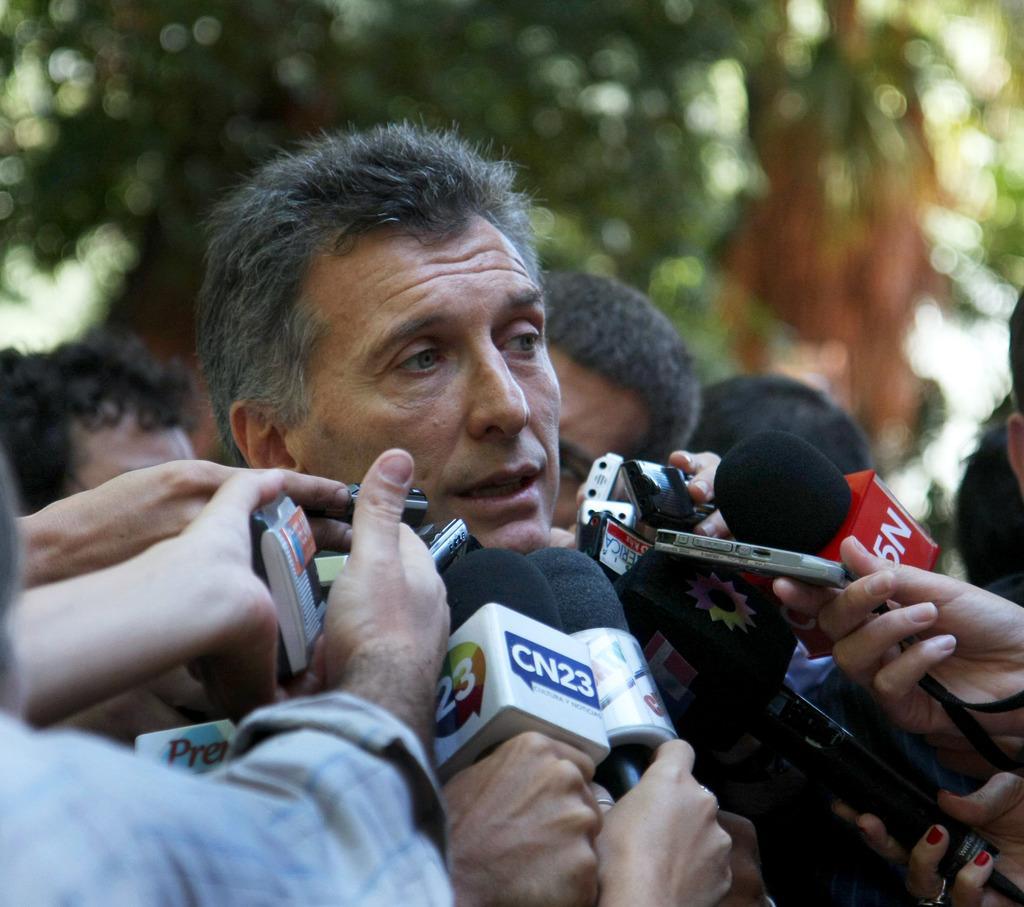Could you give a brief overview of what you see in this image? In this image I can see group of people standing. I can also see few persons hands holding few microphones, background I can see trees in green color and the sky is in white color. 